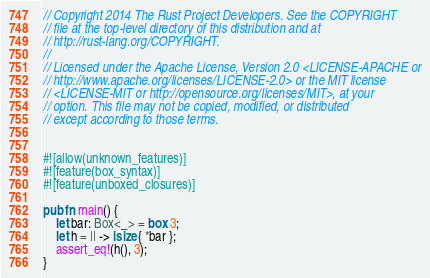Convert code to text. <code><loc_0><loc_0><loc_500><loc_500><_Rust_>// Copyright 2014 The Rust Project Developers. See the COPYRIGHT
// file at the top-level directory of this distribution and at
// http://rust-lang.org/COPYRIGHT.
//
// Licensed under the Apache License, Version 2.0 <LICENSE-APACHE or
// http://www.apache.org/licenses/LICENSE-2.0> or the MIT license
// <LICENSE-MIT or http://opensource.org/licenses/MIT>, at your
// option. This file may not be copied, modified, or distributed
// except according to those terms.


#![allow(unknown_features)]
#![feature(box_syntax)]
#![feature(unboxed_closures)]

pub fn main() {
    let bar: Box<_> = box 3;
    let h = || -> isize { *bar };
    assert_eq!(h(), 3);
}
</code> 